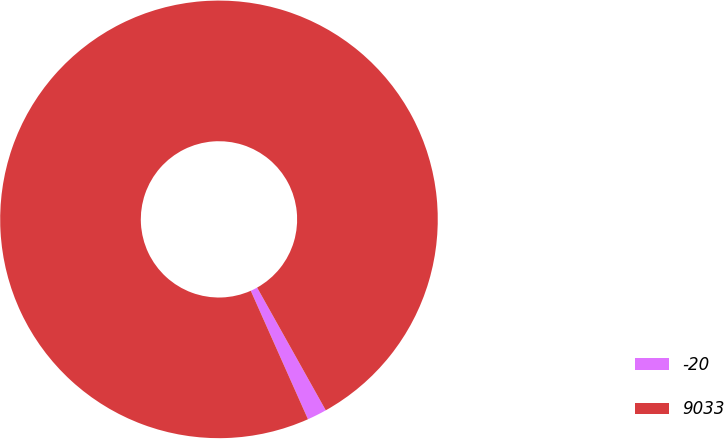<chart> <loc_0><loc_0><loc_500><loc_500><pie_chart><fcel>-20<fcel>9033<nl><fcel>1.45%<fcel>98.55%<nl></chart> 